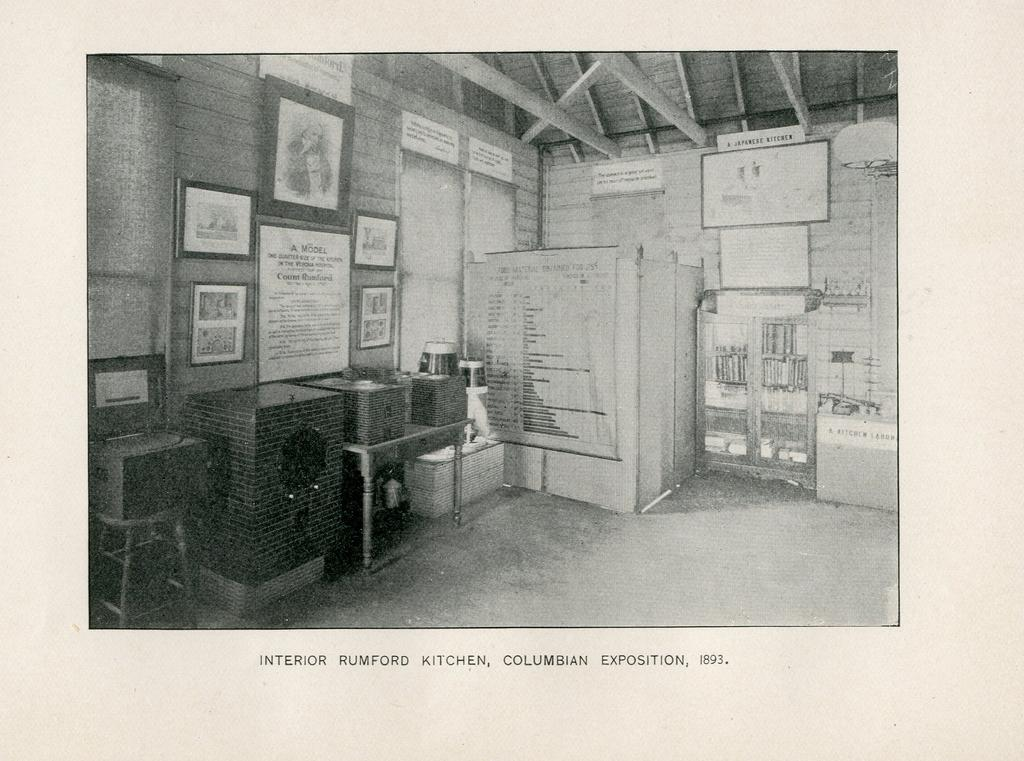What type of image is being described? The image is a photograph. What type of furniture can be seen in the image? There are tables and chairs in the image. What type of decorative items are present in the image? There are wall frames and a board on the right side of the image. What type of storage or display feature is present in the image? There is a shelf in the image. Can you tell me which actor is sitting on the chair in the image? There are no actors present in the image; it features furniture and decorative items. What type of vegetable is growing on the shelf in the image? There are no vegetables present in the image, and the shelf is not shown to be a garden or a place for growing plants. 